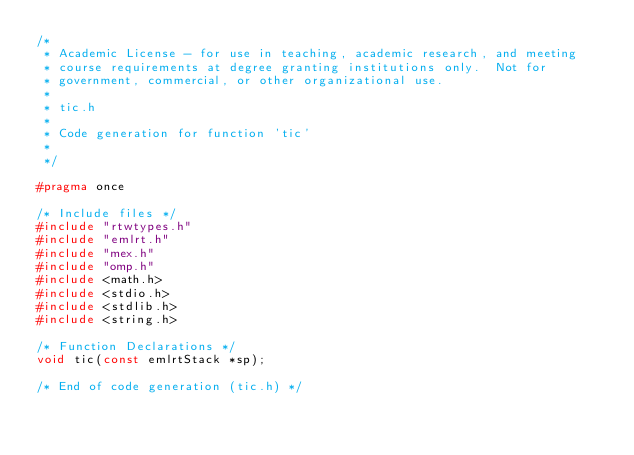Convert code to text. <code><loc_0><loc_0><loc_500><loc_500><_C_>/*
 * Academic License - for use in teaching, academic research, and meeting
 * course requirements at degree granting institutions only.  Not for
 * government, commercial, or other organizational use.
 *
 * tic.h
 *
 * Code generation for function 'tic'
 *
 */

#pragma once

/* Include files */
#include "rtwtypes.h"
#include "emlrt.h"
#include "mex.h"
#include "omp.h"
#include <math.h>
#include <stdio.h>
#include <stdlib.h>
#include <string.h>

/* Function Declarations */
void tic(const emlrtStack *sp);

/* End of code generation (tic.h) */
</code> 